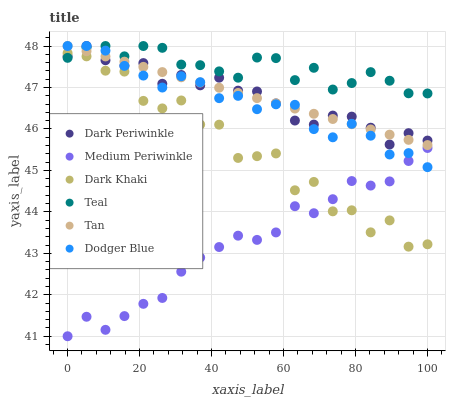Does Medium Periwinkle have the minimum area under the curve?
Answer yes or no. Yes. Does Teal have the maximum area under the curve?
Answer yes or no. Yes. Does Dark Khaki have the minimum area under the curve?
Answer yes or no. No. Does Dark Khaki have the maximum area under the curve?
Answer yes or no. No. Is Tan the smoothest?
Answer yes or no. Yes. Is Dark Khaki the roughest?
Answer yes or no. Yes. Is Dodger Blue the smoothest?
Answer yes or no. No. Is Dodger Blue the roughest?
Answer yes or no. No. Does Medium Periwinkle have the lowest value?
Answer yes or no. Yes. Does Dark Khaki have the lowest value?
Answer yes or no. No. Does Dark Periwinkle have the highest value?
Answer yes or no. Yes. Does Dark Khaki have the highest value?
Answer yes or no. No. Is Dark Khaki less than Dodger Blue?
Answer yes or no. Yes. Is Tan greater than Dark Khaki?
Answer yes or no. Yes. Does Dark Periwinkle intersect Dodger Blue?
Answer yes or no. Yes. Is Dark Periwinkle less than Dodger Blue?
Answer yes or no. No. Is Dark Periwinkle greater than Dodger Blue?
Answer yes or no. No. Does Dark Khaki intersect Dodger Blue?
Answer yes or no. No. 